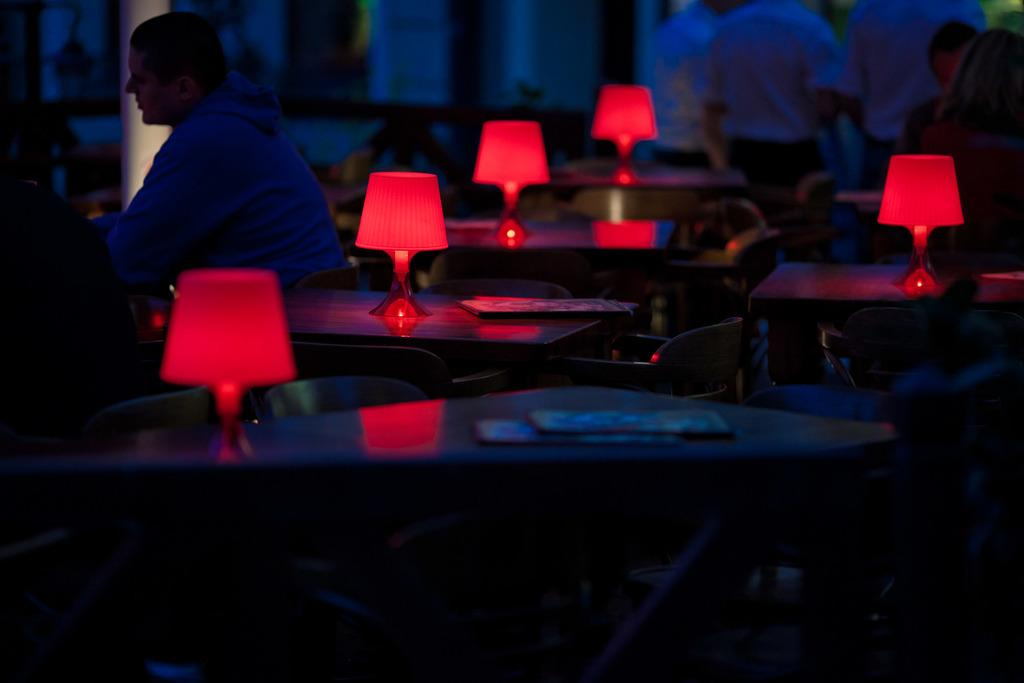How many people are in the image? There is a group of people in the image. What are some of the people in the image doing? Some people are seated on chairs, while others are standing. What can be seen on the table in the image? There are lights on a table in the image. Can you see a snake slithering across the floor in the image? No, there is no snake present in the image. What type of pear is being used as a decoration on the table in the image? There is no pear present in the image; only lights are visible on the table. 